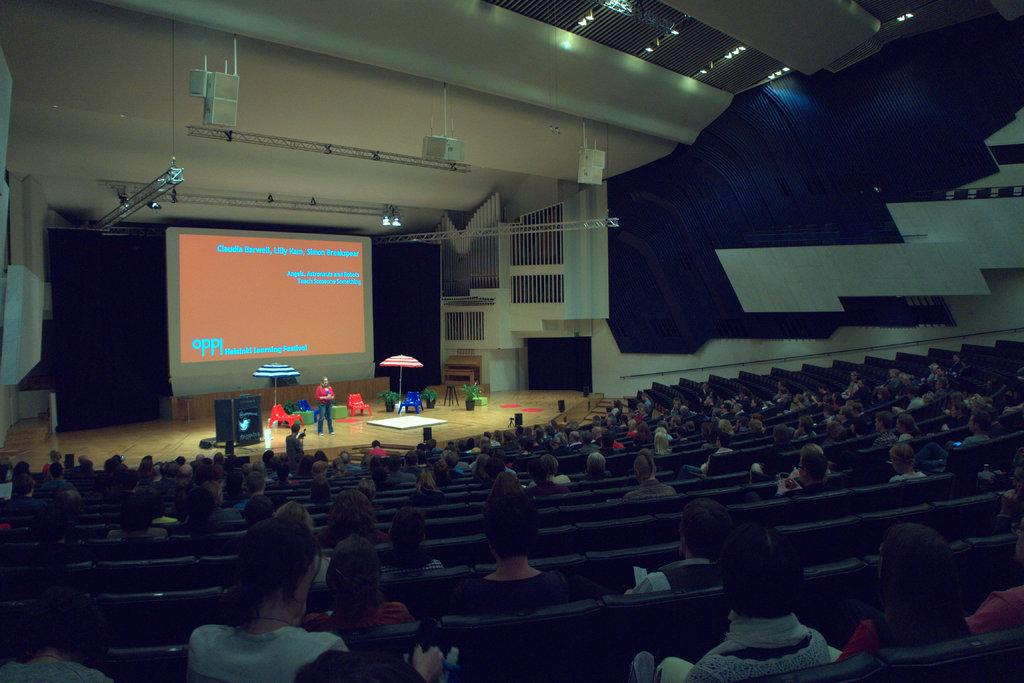<image>
Share a concise interpretation of the image provided. an auditorium with a huge screen on stage that says claudia barwell on it 